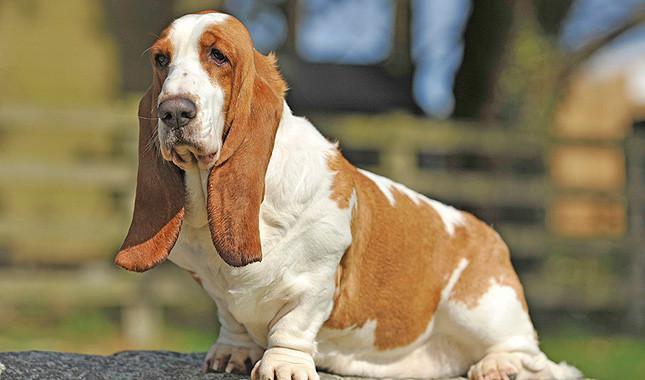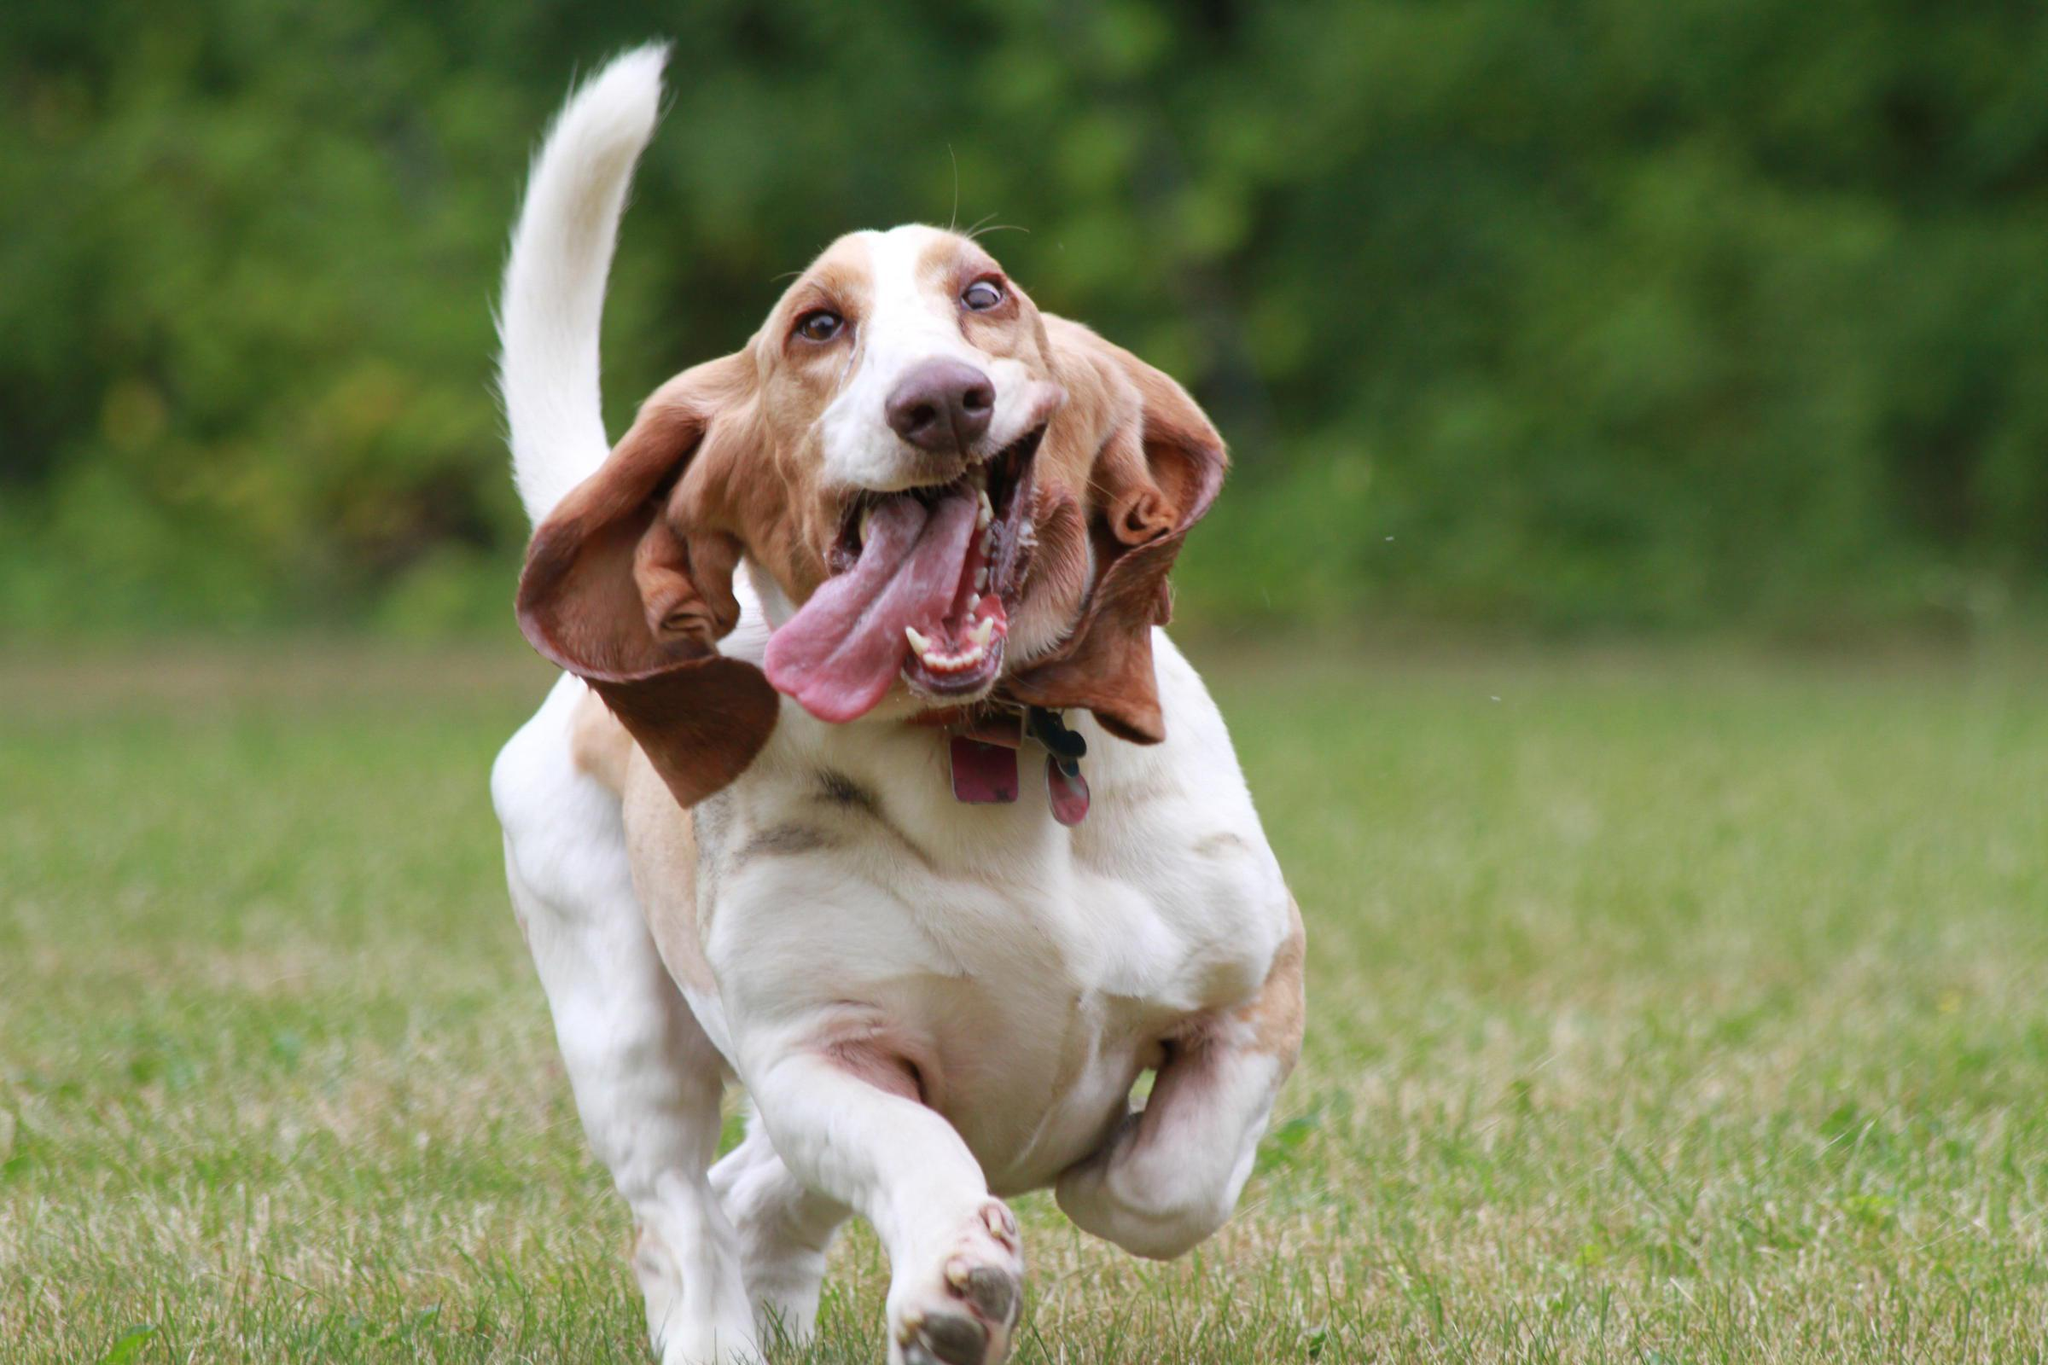The first image is the image on the left, the second image is the image on the right. Evaluate the accuracy of this statement regarding the images: "One image shows a basset hound bounding toward the camera.". Is it true? Answer yes or no. Yes. The first image is the image on the left, the second image is the image on the right. For the images displayed, is the sentence "In one image, a dog with big floppy ears is running." factually correct? Answer yes or no. Yes. 